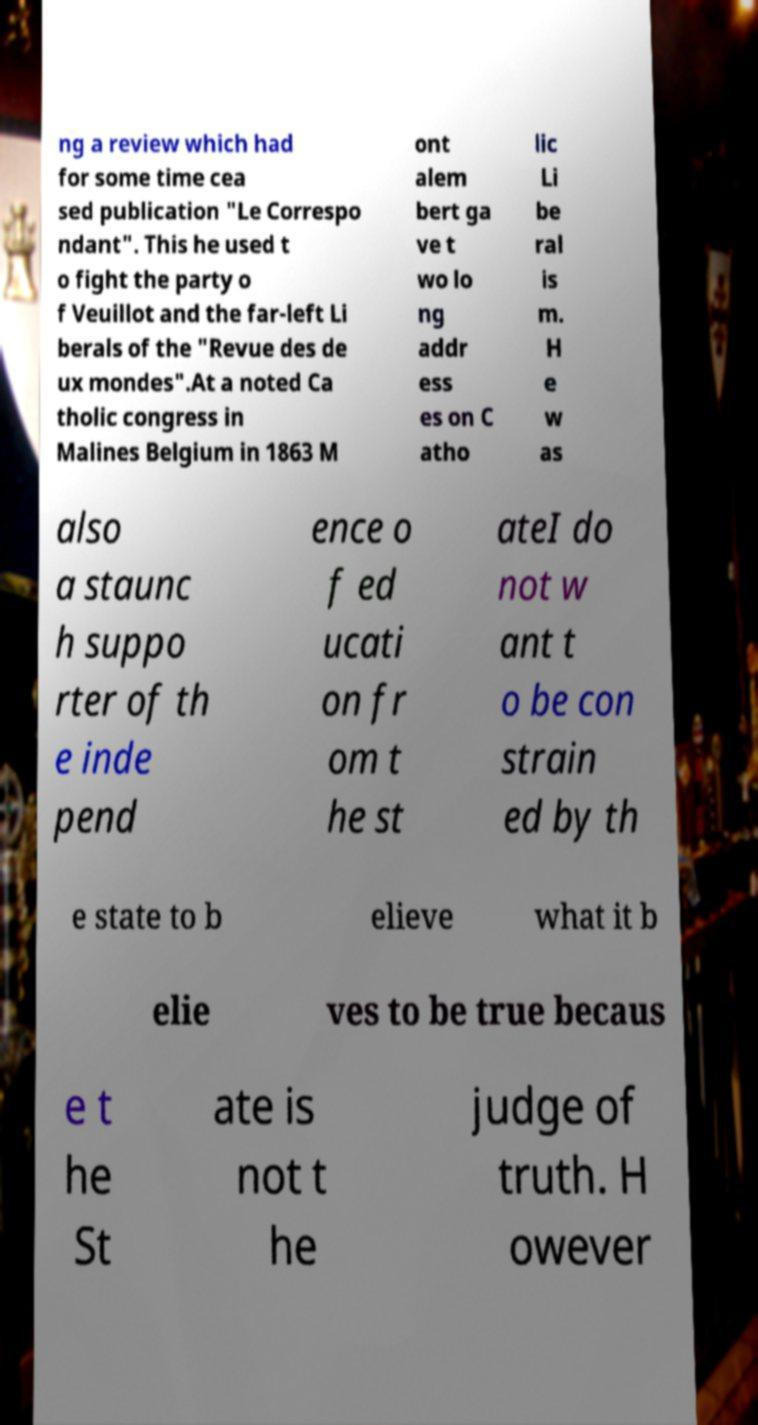For documentation purposes, I need the text within this image transcribed. Could you provide that? ng a review which had for some time cea sed publication "Le Correspo ndant". This he used t o fight the party o f Veuillot and the far-left Li berals of the "Revue des de ux mondes".At a noted Ca tholic congress in Malines Belgium in 1863 M ont alem bert ga ve t wo lo ng addr ess es on C atho lic Li be ral is m. H e w as also a staunc h suppo rter of th e inde pend ence o f ed ucati on fr om t he st ateI do not w ant t o be con strain ed by th e state to b elieve what it b elie ves to be true becaus e t he St ate is not t he judge of truth. H owever 